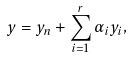Convert formula to latex. <formula><loc_0><loc_0><loc_500><loc_500>y = y _ { n } + \sum _ { i = 1 } ^ { r } \alpha _ { i } y _ { i } ,</formula> 